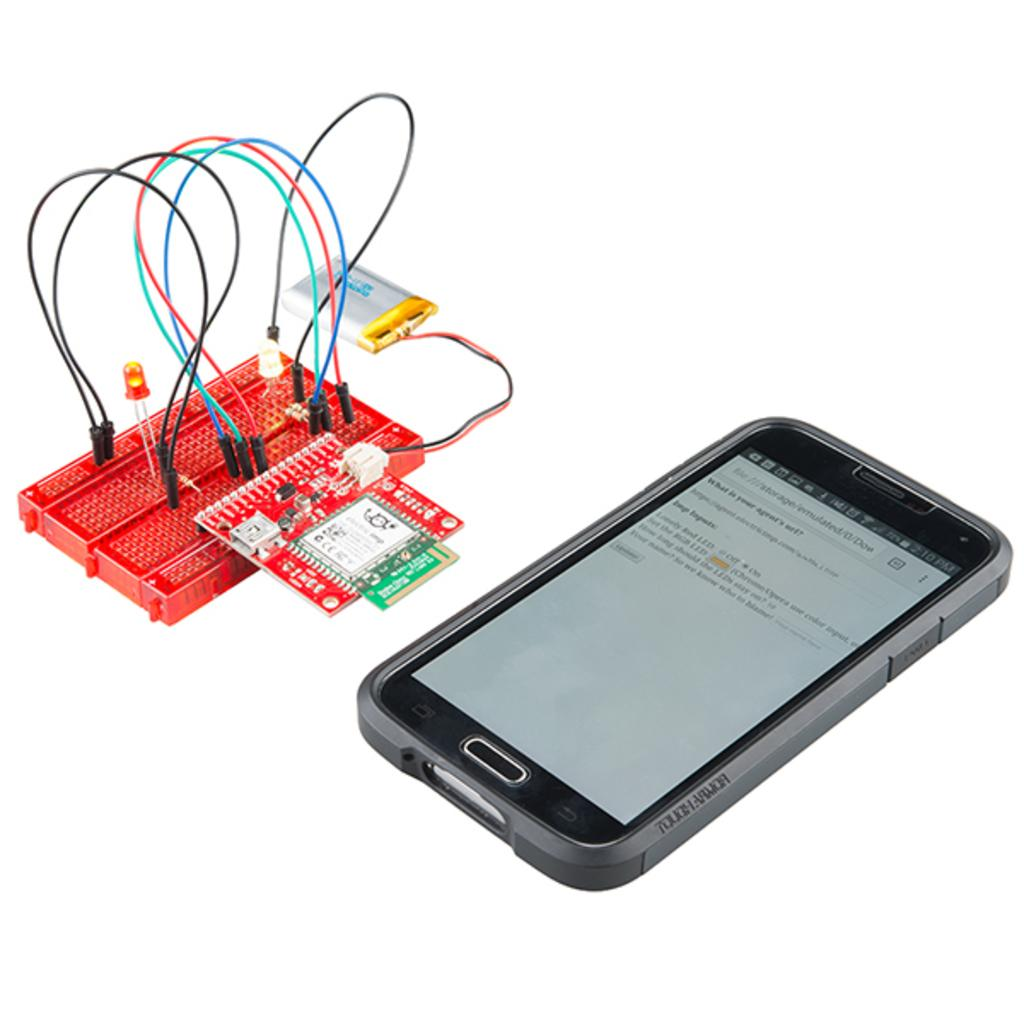Provide a one-sentence caption for the provided image. A phone with the time 2:10 P.M. and a circuit board. 